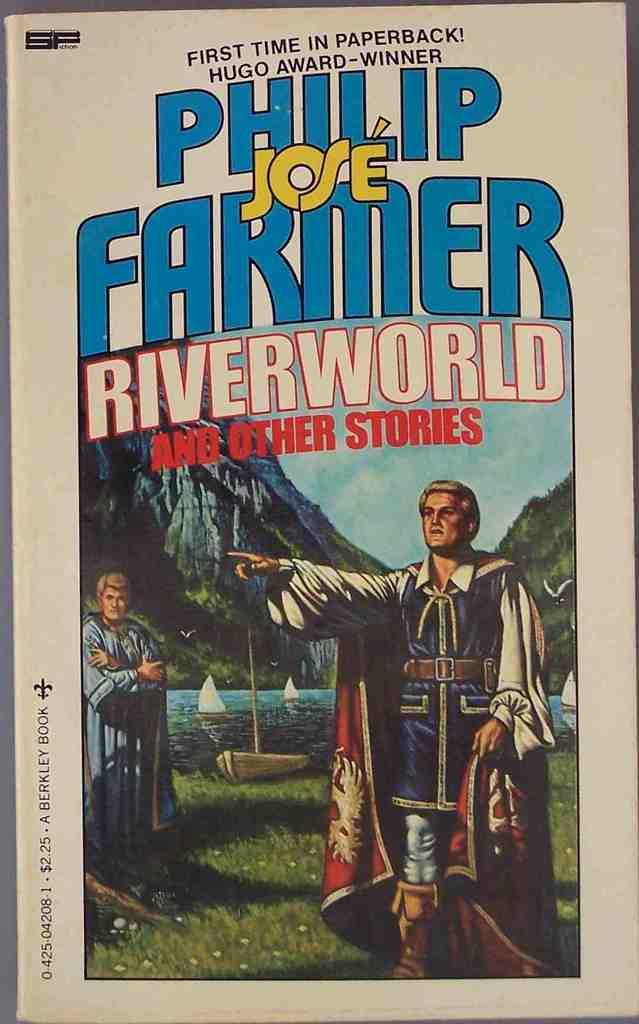What is the title of this book?
Offer a terse response. Riverworld and other stories. 